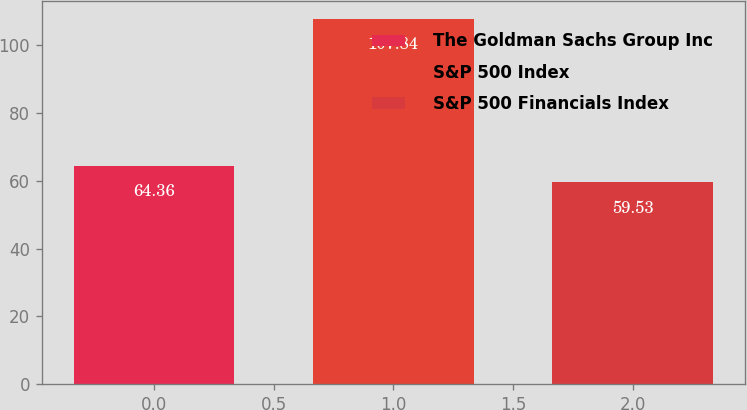<chart> <loc_0><loc_0><loc_500><loc_500><bar_chart><fcel>The Goldman Sachs Group Inc<fcel>S&P 500 Index<fcel>S&P 500 Financials Index<nl><fcel>64.36<fcel>107.84<fcel>59.53<nl></chart> 